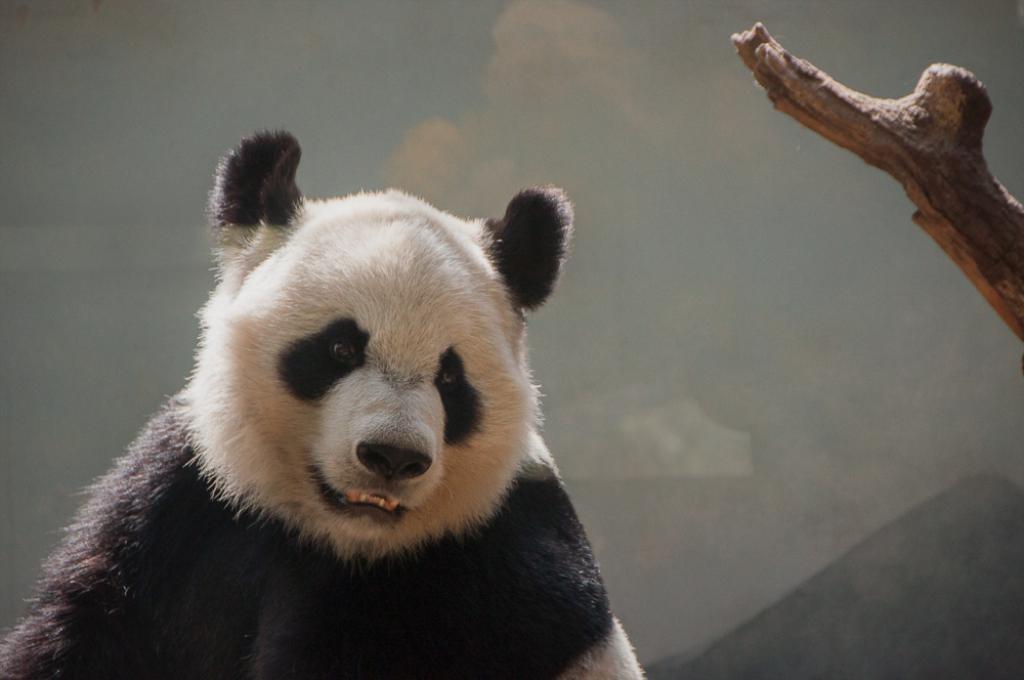Could you give a brief overview of what you see in this image? It is a bear which is in black and white color. On the right side it is a branch of a tree. 